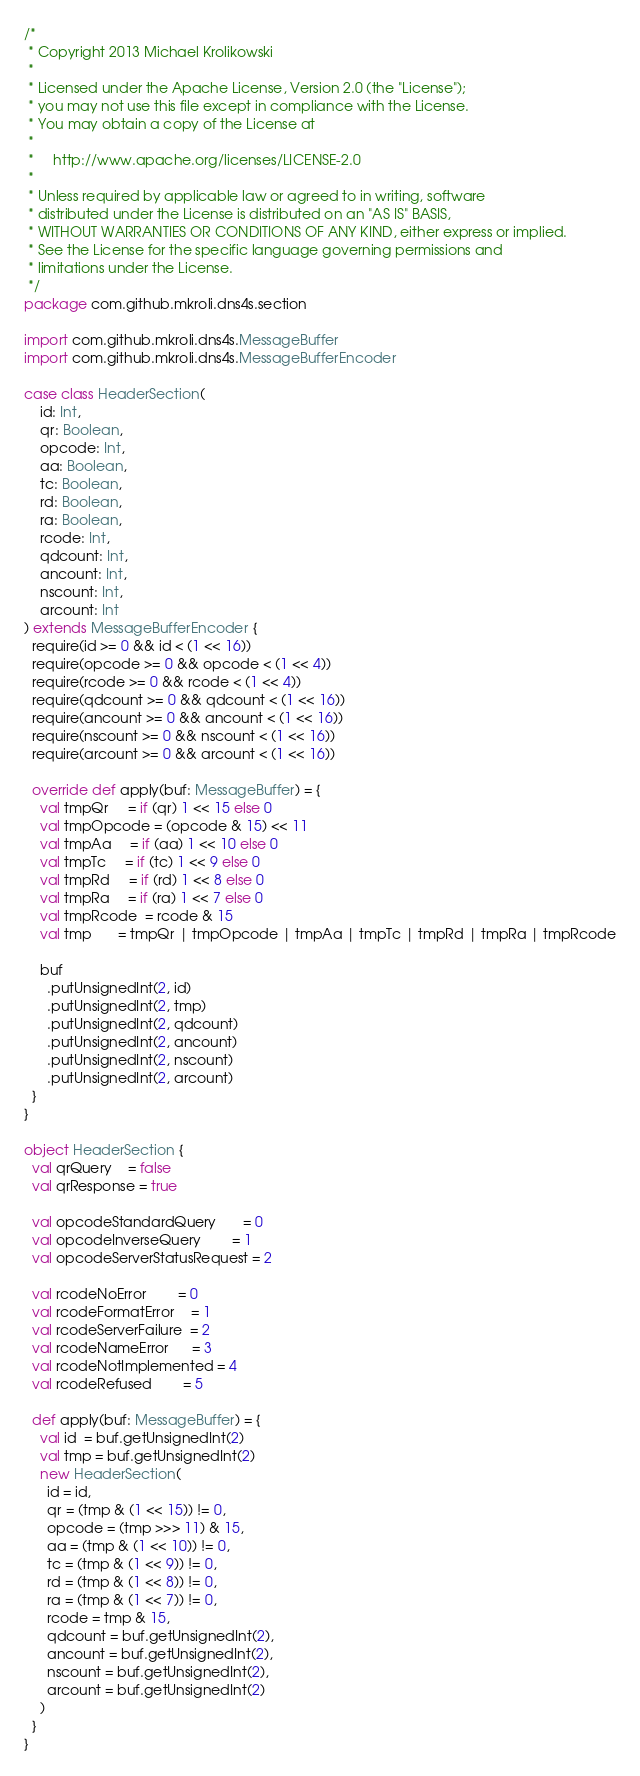<code> <loc_0><loc_0><loc_500><loc_500><_Scala_>/*
 * Copyright 2013 Michael Krolikowski
 *
 * Licensed under the Apache License, Version 2.0 (the "License");
 * you may not use this file except in compliance with the License.
 * You may obtain a copy of the License at
 *
 *     http://www.apache.org/licenses/LICENSE-2.0
 *
 * Unless required by applicable law or agreed to in writing, software
 * distributed under the License is distributed on an "AS IS" BASIS,
 * WITHOUT WARRANTIES OR CONDITIONS OF ANY KIND, either express or implied.
 * See the License for the specific language governing permissions and
 * limitations under the License.
 */
package com.github.mkroli.dns4s.section

import com.github.mkroli.dns4s.MessageBuffer
import com.github.mkroli.dns4s.MessageBufferEncoder

case class HeaderSection(
    id: Int,
    qr: Boolean,
    opcode: Int,
    aa: Boolean,
    tc: Boolean,
    rd: Boolean,
    ra: Boolean,
    rcode: Int,
    qdcount: Int,
    ancount: Int,
    nscount: Int,
    arcount: Int
) extends MessageBufferEncoder {
  require(id >= 0 && id < (1 << 16))
  require(opcode >= 0 && opcode < (1 << 4))
  require(rcode >= 0 && rcode < (1 << 4))
  require(qdcount >= 0 && qdcount < (1 << 16))
  require(ancount >= 0 && ancount < (1 << 16))
  require(nscount >= 0 && nscount < (1 << 16))
  require(arcount >= 0 && arcount < (1 << 16))

  override def apply(buf: MessageBuffer) = {
    val tmpQr     = if (qr) 1 << 15 else 0
    val tmpOpcode = (opcode & 15) << 11
    val tmpAa     = if (aa) 1 << 10 else 0
    val tmpTc     = if (tc) 1 << 9 else 0
    val tmpRd     = if (rd) 1 << 8 else 0
    val tmpRa     = if (ra) 1 << 7 else 0
    val tmpRcode  = rcode & 15
    val tmp       = tmpQr | tmpOpcode | tmpAa | tmpTc | tmpRd | tmpRa | tmpRcode

    buf
      .putUnsignedInt(2, id)
      .putUnsignedInt(2, tmp)
      .putUnsignedInt(2, qdcount)
      .putUnsignedInt(2, ancount)
      .putUnsignedInt(2, nscount)
      .putUnsignedInt(2, arcount)
  }
}

object HeaderSection {
  val qrQuery    = false
  val qrResponse = true

  val opcodeStandardQuery       = 0
  val opcodeInverseQuery        = 1
  val opcodeServerStatusRequest = 2

  val rcodeNoError        = 0
  val rcodeFormatError    = 1
  val rcodeServerFailure  = 2
  val rcodeNameError      = 3
  val rcodeNotImplemented = 4
  val rcodeRefused        = 5

  def apply(buf: MessageBuffer) = {
    val id  = buf.getUnsignedInt(2)
    val tmp = buf.getUnsignedInt(2)
    new HeaderSection(
      id = id,
      qr = (tmp & (1 << 15)) != 0,
      opcode = (tmp >>> 11) & 15,
      aa = (tmp & (1 << 10)) != 0,
      tc = (tmp & (1 << 9)) != 0,
      rd = (tmp & (1 << 8)) != 0,
      ra = (tmp & (1 << 7)) != 0,
      rcode = tmp & 15,
      qdcount = buf.getUnsignedInt(2),
      ancount = buf.getUnsignedInt(2),
      nscount = buf.getUnsignedInt(2),
      arcount = buf.getUnsignedInt(2)
    )
  }
}
</code> 